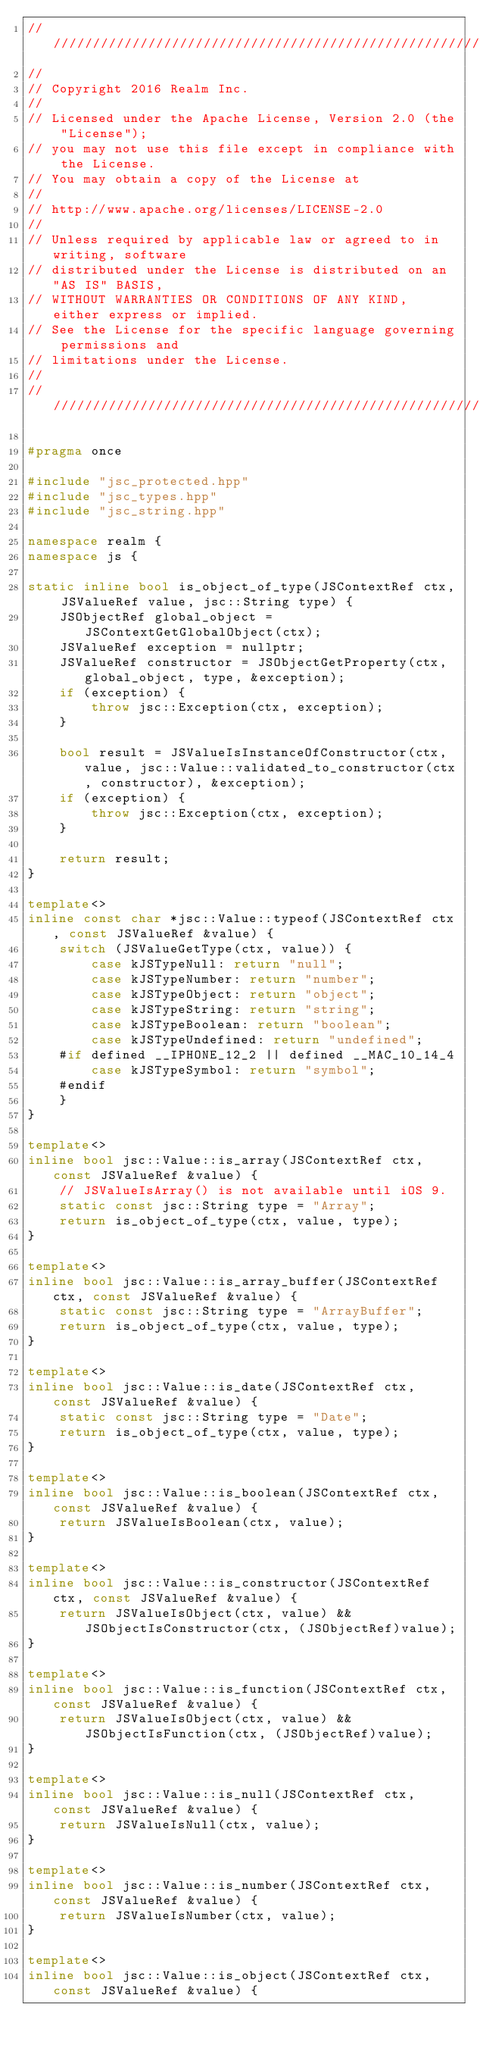Convert code to text. <code><loc_0><loc_0><loc_500><loc_500><_C++_>////////////////////////////////////////////////////////////////////////////
//
// Copyright 2016 Realm Inc.
//
// Licensed under the Apache License, Version 2.0 (the "License");
// you may not use this file except in compliance with the License.
// You may obtain a copy of the License at
//
// http://www.apache.org/licenses/LICENSE-2.0
//
// Unless required by applicable law or agreed to in writing, software
// distributed under the License is distributed on an "AS IS" BASIS,
// WITHOUT WARRANTIES OR CONDITIONS OF ANY KIND, either express or implied.
// See the License for the specific language governing permissions and
// limitations under the License.
//
////////////////////////////////////////////////////////////////////////////

#pragma once

#include "jsc_protected.hpp"
#include "jsc_types.hpp"
#include "jsc_string.hpp"

namespace realm {
namespace js {

static inline bool is_object_of_type(JSContextRef ctx, JSValueRef value, jsc::String type) {
    JSObjectRef global_object = JSContextGetGlobalObject(ctx);
    JSValueRef exception = nullptr;
    JSValueRef constructor = JSObjectGetProperty(ctx, global_object, type, &exception);
    if (exception) {
        throw jsc::Exception(ctx, exception);
    }

    bool result = JSValueIsInstanceOfConstructor(ctx, value, jsc::Value::validated_to_constructor(ctx, constructor), &exception);
    if (exception) {
        throw jsc::Exception(ctx, exception);
    }

    return result;
}

template<>
inline const char *jsc::Value::typeof(JSContextRef ctx, const JSValueRef &value) {
    switch (JSValueGetType(ctx, value)) {
        case kJSTypeNull: return "null";
        case kJSTypeNumber: return "number";
        case kJSTypeObject: return "object";
        case kJSTypeString: return "string";
        case kJSTypeBoolean: return "boolean";
        case kJSTypeUndefined: return "undefined";
    #if defined __IPHONE_12_2 || defined __MAC_10_14_4
        case kJSTypeSymbol: return "symbol";
    #endif
    }
}

template<>
inline bool jsc::Value::is_array(JSContextRef ctx, const JSValueRef &value) {
    // JSValueIsArray() is not available until iOS 9.
    static const jsc::String type = "Array";
    return is_object_of_type(ctx, value, type);
}

template<>
inline bool jsc::Value::is_array_buffer(JSContextRef ctx, const JSValueRef &value) {
    static const jsc::String type = "ArrayBuffer";
    return is_object_of_type(ctx, value, type);
}

template<>
inline bool jsc::Value::is_date(JSContextRef ctx, const JSValueRef &value) {
    static const jsc::String type = "Date";
    return is_object_of_type(ctx, value, type);
}

template<>
inline bool jsc::Value::is_boolean(JSContextRef ctx, const JSValueRef &value) {
    return JSValueIsBoolean(ctx, value);
}

template<>
inline bool jsc::Value::is_constructor(JSContextRef ctx, const JSValueRef &value) {
    return JSValueIsObject(ctx, value) && JSObjectIsConstructor(ctx, (JSObjectRef)value);
}

template<>
inline bool jsc::Value::is_function(JSContextRef ctx, const JSValueRef &value) {
    return JSValueIsObject(ctx, value) && JSObjectIsFunction(ctx, (JSObjectRef)value);
}

template<>
inline bool jsc::Value::is_null(JSContextRef ctx, const JSValueRef &value) {
    return JSValueIsNull(ctx, value);
}

template<>
inline bool jsc::Value::is_number(JSContextRef ctx, const JSValueRef &value) {
    return JSValueIsNumber(ctx, value);
}

template<>
inline bool jsc::Value::is_object(JSContextRef ctx, const JSValueRef &value) {</code> 